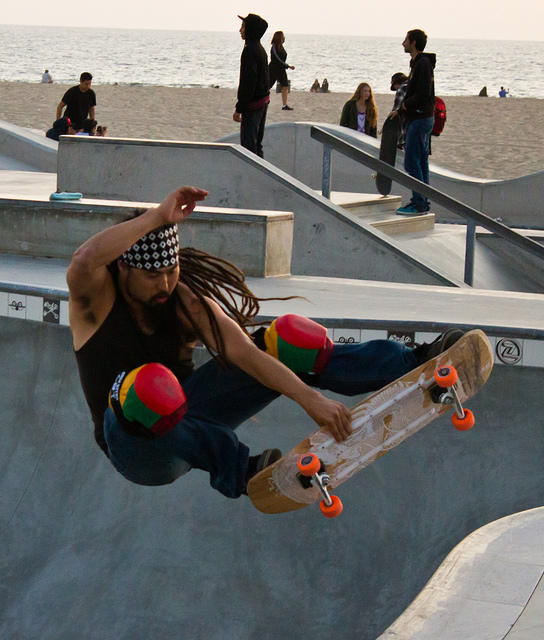<image>Does this appear to be a California beach? I am not sure if this is a California beach. It could be. Does this appear to be a California beach? I don't know if this appears to be a California beach. It can be either a California beach or not. 